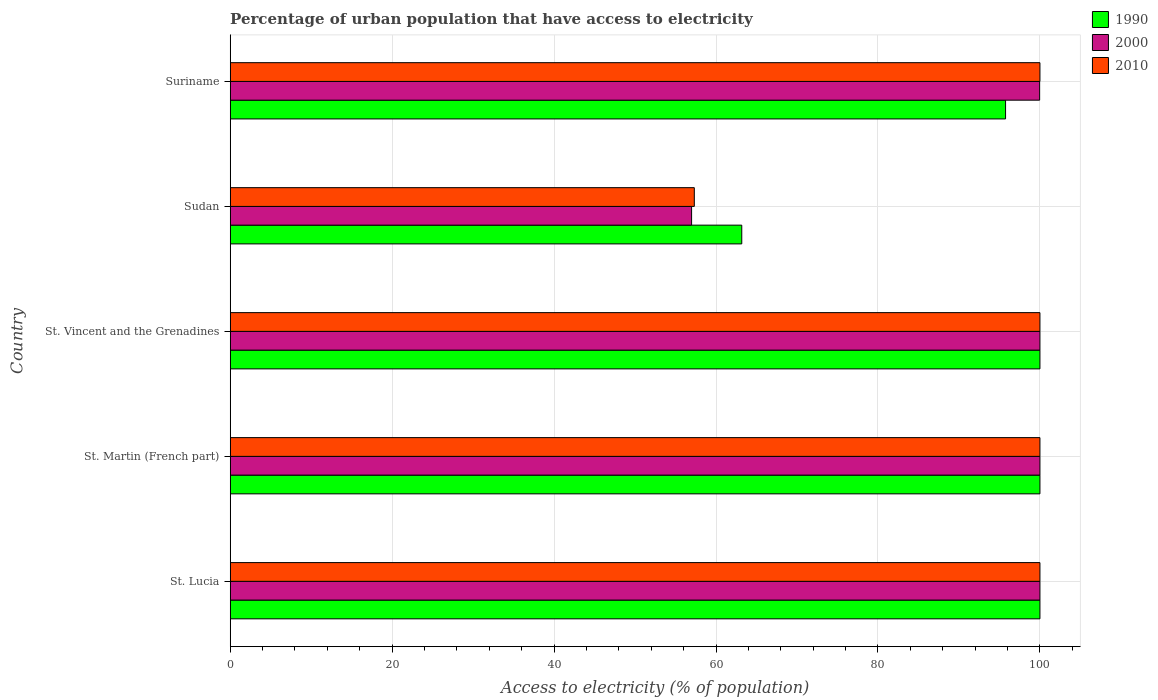How many groups of bars are there?
Give a very brief answer. 5. Are the number of bars on each tick of the Y-axis equal?
Provide a succinct answer. Yes. What is the label of the 5th group of bars from the top?
Ensure brevity in your answer.  St. Lucia. What is the percentage of urban population that have access to electricity in 2000 in Suriname?
Your answer should be compact. 99.96. Across all countries, what is the minimum percentage of urban population that have access to electricity in 1990?
Your answer should be compact. 63.18. In which country was the percentage of urban population that have access to electricity in 2010 maximum?
Make the answer very short. St. Lucia. In which country was the percentage of urban population that have access to electricity in 1990 minimum?
Ensure brevity in your answer.  Sudan. What is the total percentage of urban population that have access to electricity in 1990 in the graph?
Your answer should be very brief. 458.93. What is the difference between the percentage of urban population that have access to electricity in 1990 in St. Martin (French part) and that in Suriname?
Give a very brief answer. 4.24. What is the difference between the percentage of urban population that have access to electricity in 2010 in Sudan and the percentage of urban population that have access to electricity in 2000 in St. Lucia?
Keep it short and to the point. -42.68. What is the average percentage of urban population that have access to electricity in 1990 per country?
Your response must be concise. 91.79. What is the difference between the percentage of urban population that have access to electricity in 1990 and percentage of urban population that have access to electricity in 2000 in Suriname?
Give a very brief answer. -4.21. In how many countries, is the percentage of urban population that have access to electricity in 1990 greater than 12 %?
Your answer should be very brief. 5. Is the percentage of urban population that have access to electricity in 2010 in St. Martin (French part) less than that in Sudan?
Your answer should be very brief. No. Is the difference between the percentage of urban population that have access to electricity in 1990 in St. Martin (French part) and Sudan greater than the difference between the percentage of urban population that have access to electricity in 2000 in St. Martin (French part) and Sudan?
Provide a short and direct response. No. What is the difference between the highest and the second highest percentage of urban population that have access to electricity in 2000?
Provide a succinct answer. 0. What is the difference between the highest and the lowest percentage of urban population that have access to electricity in 1990?
Your response must be concise. 36.82. In how many countries, is the percentage of urban population that have access to electricity in 2000 greater than the average percentage of urban population that have access to electricity in 2000 taken over all countries?
Offer a terse response. 4. What does the 1st bar from the bottom in St. Lucia represents?
Provide a succinct answer. 1990. Is it the case that in every country, the sum of the percentage of urban population that have access to electricity in 2000 and percentage of urban population that have access to electricity in 2010 is greater than the percentage of urban population that have access to electricity in 1990?
Offer a terse response. Yes. How many countries are there in the graph?
Your answer should be very brief. 5. Are the values on the major ticks of X-axis written in scientific E-notation?
Offer a very short reply. No. Does the graph contain any zero values?
Give a very brief answer. No. How are the legend labels stacked?
Provide a succinct answer. Vertical. What is the title of the graph?
Make the answer very short. Percentage of urban population that have access to electricity. What is the label or title of the X-axis?
Ensure brevity in your answer.  Access to electricity (% of population). What is the label or title of the Y-axis?
Your answer should be compact. Country. What is the Access to electricity (% of population) in 1990 in St. Lucia?
Give a very brief answer. 100. What is the Access to electricity (% of population) in 2000 in St. Lucia?
Offer a terse response. 100. What is the Access to electricity (% of population) in 2010 in St. Lucia?
Offer a very short reply. 100. What is the Access to electricity (% of population) of 1990 in St. Vincent and the Grenadines?
Ensure brevity in your answer.  100. What is the Access to electricity (% of population) of 2010 in St. Vincent and the Grenadines?
Provide a short and direct response. 100. What is the Access to electricity (% of population) in 1990 in Sudan?
Your answer should be very brief. 63.18. What is the Access to electricity (% of population) of 2000 in Sudan?
Keep it short and to the point. 56.98. What is the Access to electricity (% of population) of 2010 in Sudan?
Your answer should be very brief. 57.32. What is the Access to electricity (% of population) of 1990 in Suriname?
Your answer should be very brief. 95.76. What is the Access to electricity (% of population) in 2000 in Suriname?
Your answer should be very brief. 99.96. What is the Access to electricity (% of population) in 2010 in Suriname?
Offer a very short reply. 100. Across all countries, what is the minimum Access to electricity (% of population) of 1990?
Ensure brevity in your answer.  63.18. Across all countries, what is the minimum Access to electricity (% of population) of 2000?
Ensure brevity in your answer.  56.98. Across all countries, what is the minimum Access to electricity (% of population) of 2010?
Your response must be concise. 57.32. What is the total Access to electricity (% of population) in 1990 in the graph?
Your answer should be compact. 458.93. What is the total Access to electricity (% of population) in 2000 in the graph?
Make the answer very short. 456.94. What is the total Access to electricity (% of population) in 2010 in the graph?
Your answer should be very brief. 457.32. What is the difference between the Access to electricity (% of population) of 2010 in St. Lucia and that in St. Martin (French part)?
Your answer should be very brief. 0. What is the difference between the Access to electricity (% of population) of 1990 in St. Lucia and that in St. Vincent and the Grenadines?
Your answer should be compact. 0. What is the difference between the Access to electricity (% of population) in 2010 in St. Lucia and that in St. Vincent and the Grenadines?
Offer a terse response. 0. What is the difference between the Access to electricity (% of population) in 1990 in St. Lucia and that in Sudan?
Keep it short and to the point. 36.82. What is the difference between the Access to electricity (% of population) in 2000 in St. Lucia and that in Sudan?
Provide a succinct answer. 43.02. What is the difference between the Access to electricity (% of population) of 2010 in St. Lucia and that in Sudan?
Ensure brevity in your answer.  42.68. What is the difference between the Access to electricity (% of population) of 1990 in St. Lucia and that in Suriname?
Your answer should be very brief. 4.24. What is the difference between the Access to electricity (% of population) of 2000 in St. Lucia and that in Suriname?
Ensure brevity in your answer.  0.04. What is the difference between the Access to electricity (% of population) of 2010 in St. Lucia and that in Suriname?
Ensure brevity in your answer.  0. What is the difference between the Access to electricity (% of population) in 2000 in St. Martin (French part) and that in St. Vincent and the Grenadines?
Provide a short and direct response. 0. What is the difference between the Access to electricity (% of population) in 1990 in St. Martin (French part) and that in Sudan?
Provide a succinct answer. 36.82. What is the difference between the Access to electricity (% of population) in 2000 in St. Martin (French part) and that in Sudan?
Make the answer very short. 43.02. What is the difference between the Access to electricity (% of population) in 2010 in St. Martin (French part) and that in Sudan?
Your answer should be very brief. 42.68. What is the difference between the Access to electricity (% of population) in 1990 in St. Martin (French part) and that in Suriname?
Provide a short and direct response. 4.24. What is the difference between the Access to electricity (% of population) in 2000 in St. Martin (French part) and that in Suriname?
Your answer should be compact. 0.04. What is the difference between the Access to electricity (% of population) of 2010 in St. Martin (French part) and that in Suriname?
Provide a short and direct response. 0. What is the difference between the Access to electricity (% of population) of 1990 in St. Vincent and the Grenadines and that in Sudan?
Provide a succinct answer. 36.82. What is the difference between the Access to electricity (% of population) of 2000 in St. Vincent and the Grenadines and that in Sudan?
Keep it short and to the point. 43.02. What is the difference between the Access to electricity (% of population) in 2010 in St. Vincent and the Grenadines and that in Sudan?
Provide a succinct answer. 42.68. What is the difference between the Access to electricity (% of population) in 1990 in St. Vincent and the Grenadines and that in Suriname?
Your answer should be very brief. 4.24. What is the difference between the Access to electricity (% of population) in 2000 in St. Vincent and the Grenadines and that in Suriname?
Your answer should be very brief. 0.04. What is the difference between the Access to electricity (% of population) in 1990 in Sudan and that in Suriname?
Your answer should be very brief. -32.58. What is the difference between the Access to electricity (% of population) of 2000 in Sudan and that in Suriname?
Your response must be concise. -42.98. What is the difference between the Access to electricity (% of population) of 2010 in Sudan and that in Suriname?
Provide a short and direct response. -42.68. What is the difference between the Access to electricity (% of population) of 1990 in St. Lucia and the Access to electricity (% of population) of 2000 in St. Martin (French part)?
Give a very brief answer. 0. What is the difference between the Access to electricity (% of population) in 1990 in St. Lucia and the Access to electricity (% of population) in 2010 in St. Martin (French part)?
Your answer should be very brief. 0. What is the difference between the Access to electricity (% of population) in 2000 in St. Lucia and the Access to electricity (% of population) in 2010 in St. Martin (French part)?
Your response must be concise. 0. What is the difference between the Access to electricity (% of population) in 1990 in St. Lucia and the Access to electricity (% of population) in 2000 in Sudan?
Provide a succinct answer. 43.02. What is the difference between the Access to electricity (% of population) of 1990 in St. Lucia and the Access to electricity (% of population) of 2010 in Sudan?
Your response must be concise. 42.68. What is the difference between the Access to electricity (% of population) in 2000 in St. Lucia and the Access to electricity (% of population) in 2010 in Sudan?
Give a very brief answer. 42.68. What is the difference between the Access to electricity (% of population) in 1990 in St. Lucia and the Access to electricity (% of population) in 2000 in Suriname?
Ensure brevity in your answer.  0.04. What is the difference between the Access to electricity (% of population) of 1990 in St. Lucia and the Access to electricity (% of population) of 2010 in Suriname?
Ensure brevity in your answer.  0. What is the difference between the Access to electricity (% of population) of 1990 in St. Martin (French part) and the Access to electricity (% of population) of 2000 in St. Vincent and the Grenadines?
Ensure brevity in your answer.  0. What is the difference between the Access to electricity (% of population) in 2000 in St. Martin (French part) and the Access to electricity (% of population) in 2010 in St. Vincent and the Grenadines?
Ensure brevity in your answer.  0. What is the difference between the Access to electricity (% of population) in 1990 in St. Martin (French part) and the Access to electricity (% of population) in 2000 in Sudan?
Give a very brief answer. 43.02. What is the difference between the Access to electricity (% of population) in 1990 in St. Martin (French part) and the Access to electricity (% of population) in 2010 in Sudan?
Offer a terse response. 42.68. What is the difference between the Access to electricity (% of population) of 2000 in St. Martin (French part) and the Access to electricity (% of population) of 2010 in Sudan?
Your answer should be compact. 42.68. What is the difference between the Access to electricity (% of population) of 1990 in St. Martin (French part) and the Access to electricity (% of population) of 2000 in Suriname?
Keep it short and to the point. 0.04. What is the difference between the Access to electricity (% of population) in 1990 in St. Vincent and the Grenadines and the Access to electricity (% of population) in 2000 in Sudan?
Your response must be concise. 43.02. What is the difference between the Access to electricity (% of population) of 1990 in St. Vincent and the Grenadines and the Access to electricity (% of population) of 2010 in Sudan?
Your answer should be compact. 42.68. What is the difference between the Access to electricity (% of population) in 2000 in St. Vincent and the Grenadines and the Access to electricity (% of population) in 2010 in Sudan?
Make the answer very short. 42.68. What is the difference between the Access to electricity (% of population) of 1990 in St. Vincent and the Grenadines and the Access to electricity (% of population) of 2000 in Suriname?
Offer a very short reply. 0.04. What is the difference between the Access to electricity (% of population) of 1990 in St. Vincent and the Grenadines and the Access to electricity (% of population) of 2010 in Suriname?
Make the answer very short. 0. What is the difference between the Access to electricity (% of population) in 1990 in Sudan and the Access to electricity (% of population) in 2000 in Suriname?
Your answer should be very brief. -36.78. What is the difference between the Access to electricity (% of population) in 1990 in Sudan and the Access to electricity (% of population) in 2010 in Suriname?
Make the answer very short. -36.82. What is the difference between the Access to electricity (% of population) of 2000 in Sudan and the Access to electricity (% of population) of 2010 in Suriname?
Provide a short and direct response. -43.02. What is the average Access to electricity (% of population) in 1990 per country?
Offer a very short reply. 91.79. What is the average Access to electricity (% of population) in 2000 per country?
Ensure brevity in your answer.  91.39. What is the average Access to electricity (% of population) of 2010 per country?
Make the answer very short. 91.46. What is the difference between the Access to electricity (% of population) of 1990 and Access to electricity (% of population) of 2000 in St. Lucia?
Your answer should be compact. 0. What is the difference between the Access to electricity (% of population) of 1990 and Access to electricity (% of population) of 2010 in St. Vincent and the Grenadines?
Make the answer very short. 0. What is the difference between the Access to electricity (% of population) of 2000 and Access to electricity (% of population) of 2010 in St. Vincent and the Grenadines?
Offer a terse response. 0. What is the difference between the Access to electricity (% of population) of 1990 and Access to electricity (% of population) of 2000 in Sudan?
Keep it short and to the point. 6.2. What is the difference between the Access to electricity (% of population) of 1990 and Access to electricity (% of population) of 2010 in Sudan?
Provide a succinct answer. 5.86. What is the difference between the Access to electricity (% of population) in 2000 and Access to electricity (% of population) in 2010 in Sudan?
Ensure brevity in your answer.  -0.34. What is the difference between the Access to electricity (% of population) in 1990 and Access to electricity (% of population) in 2000 in Suriname?
Keep it short and to the point. -4.21. What is the difference between the Access to electricity (% of population) in 1990 and Access to electricity (% of population) in 2010 in Suriname?
Offer a terse response. -4.24. What is the difference between the Access to electricity (% of population) in 2000 and Access to electricity (% of population) in 2010 in Suriname?
Provide a short and direct response. -0.04. What is the ratio of the Access to electricity (% of population) in 2000 in St. Lucia to that in St. Martin (French part)?
Your response must be concise. 1. What is the ratio of the Access to electricity (% of population) in 2010 in St. Lucia to that in St. Martin (French part)?
Offer a terse response. 1. What is the ratio of the Access to electricity (% of population) of 1990 in St. Lucia to that in St. Vincent and the Grenadines?
Provide a short and direct response. 1. What is the ratio of the Access to electricity (% of population) of 2000 in St. Lucia to that in St. Vincent and the Grenadines?
Offer a terse response. 1. What is the ratio of the Access to electricity (% of population) of 2010 in St. Lucia to that in St. Vincent and the Grenadines?
Provide a short and direct response. 1. What is the ratio of the Access to electricity (% of population) of 1990 in St. Lucia to that in Sudan?
Provide a short and direct response. 1.58. What is the ratio of the Access to electricity (% of population) in 2000 in St. Lucia to that in Sudan?
Offer a very short reply. 1.75. What is the ratio of the Access to electricity (% of population) of 2010 in St. Lucia to that in Sudan?
Offer a very short reply. 1.74. What is the ratio of the Access to electricity (% of population) of 1990 in St. Lucia to that in Suriname?
Provide a short and direct response. 1.04. What is the ratio of the Access to electricity (% of population) of 2010 in St. Lucia to that in Suriname?
Your answer should be very brief. 1. What is the ratio of the Access to electricity (% of population) in 1990 in St. Martin (French part) to that in St. Vincent and the Grenadines?
Ensure brevity in your answer.  1. What is the ratio of the Access to electricity (% of population) in 1990 in St. Martin (French part) to that in Sudan?
Give a very brief answer. 1.58. What is the ratio of the Access to electricity (% of population) in 2000 in St. Martin (French part) to that in Sudan?
Keep it short and to the point. 1.75. What is the ratio of the Access to electricity (% of population) of 2010 in St. Martin (French part) to that in Sudan?
Your answer should be very brief. 1.74. What is the ratio of the Access to electricity (% of population) of 1990 in St. Martin (French part) to that in Suriname?
Make the answer very short. 1.04. What is the ratio of the Access to electricity (% of population) in 2000 in St. Martin (French part) to that in Suriname?
Keep it short and to the point. 1. What is the ratio of the Access to electricity (% of population) of 1990 in St. Vincent and the Grenadines to that in Sudan?
Provide a succinct answer. 1.58. What is the ratio of the Access to electricity (% of population) in 2000 in St. Vincent and the Grenadines to that in Sudan?
Ensure brevity in your answer.  1.75. What is the ratio of the Access to electricity (% of population) of 2010 in St. Vincent and the Grenadines to that in Sudan?
Ensure brevity in your answer.  1.74. What is the ratio of the Access to electricity (% of population) in 1990 in St. Vincent and the Grenadines to that in Suriname?
Your response must be concise. 1.04. What is the ratio of the Access to electricity (% of population) of 1990 in Sudan to that in Suriname?
Offer a terse response. 0.66. What is the ratio of the Access to electricity (% of population) in 2000 in Sudan to that in Suriname?
Give a very brief answer. 0.57. What is the ratio of the Access to electricity (% of population) of 2010 in Sudan to that in Suriname?
Your answer should be very brief. 0.57. What is the difference between the highest and the lowest Access to electricity (% of population) of 1990?
Keep it short and to the point. 36.82. What is the difference between the highest and the lowest Access to electricity (% of population) in 2000?
Your response must be concise. 43.02. What is the difference between the highest and the lowest Access to electricity (% of population) in 2010?
Keep it short and to the point. 42.68. 